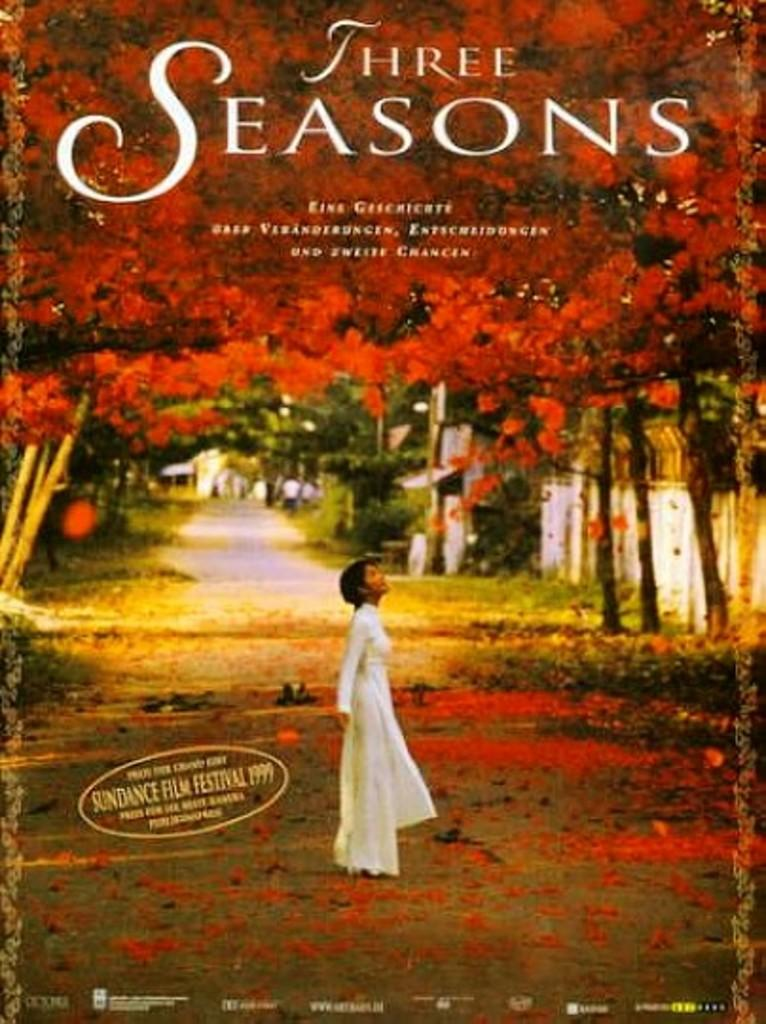Provide a one-sentence caption for the provided image. A brightly colored poster advertising the film "Three Seasons". 